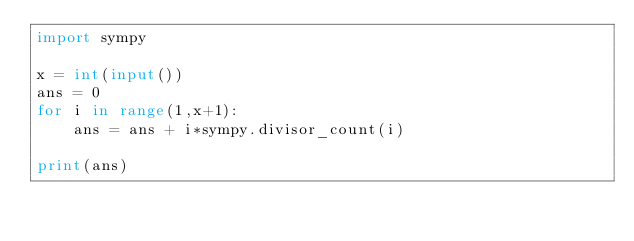<code> <loc_0><loc_0><loc_500><loc_500><_Python_>import sympy

x = int(input())
ans = 0
for i in range(1,x+1):
    ans = ans + i*sympy.divisor_count(i)

print(ans)</code> 